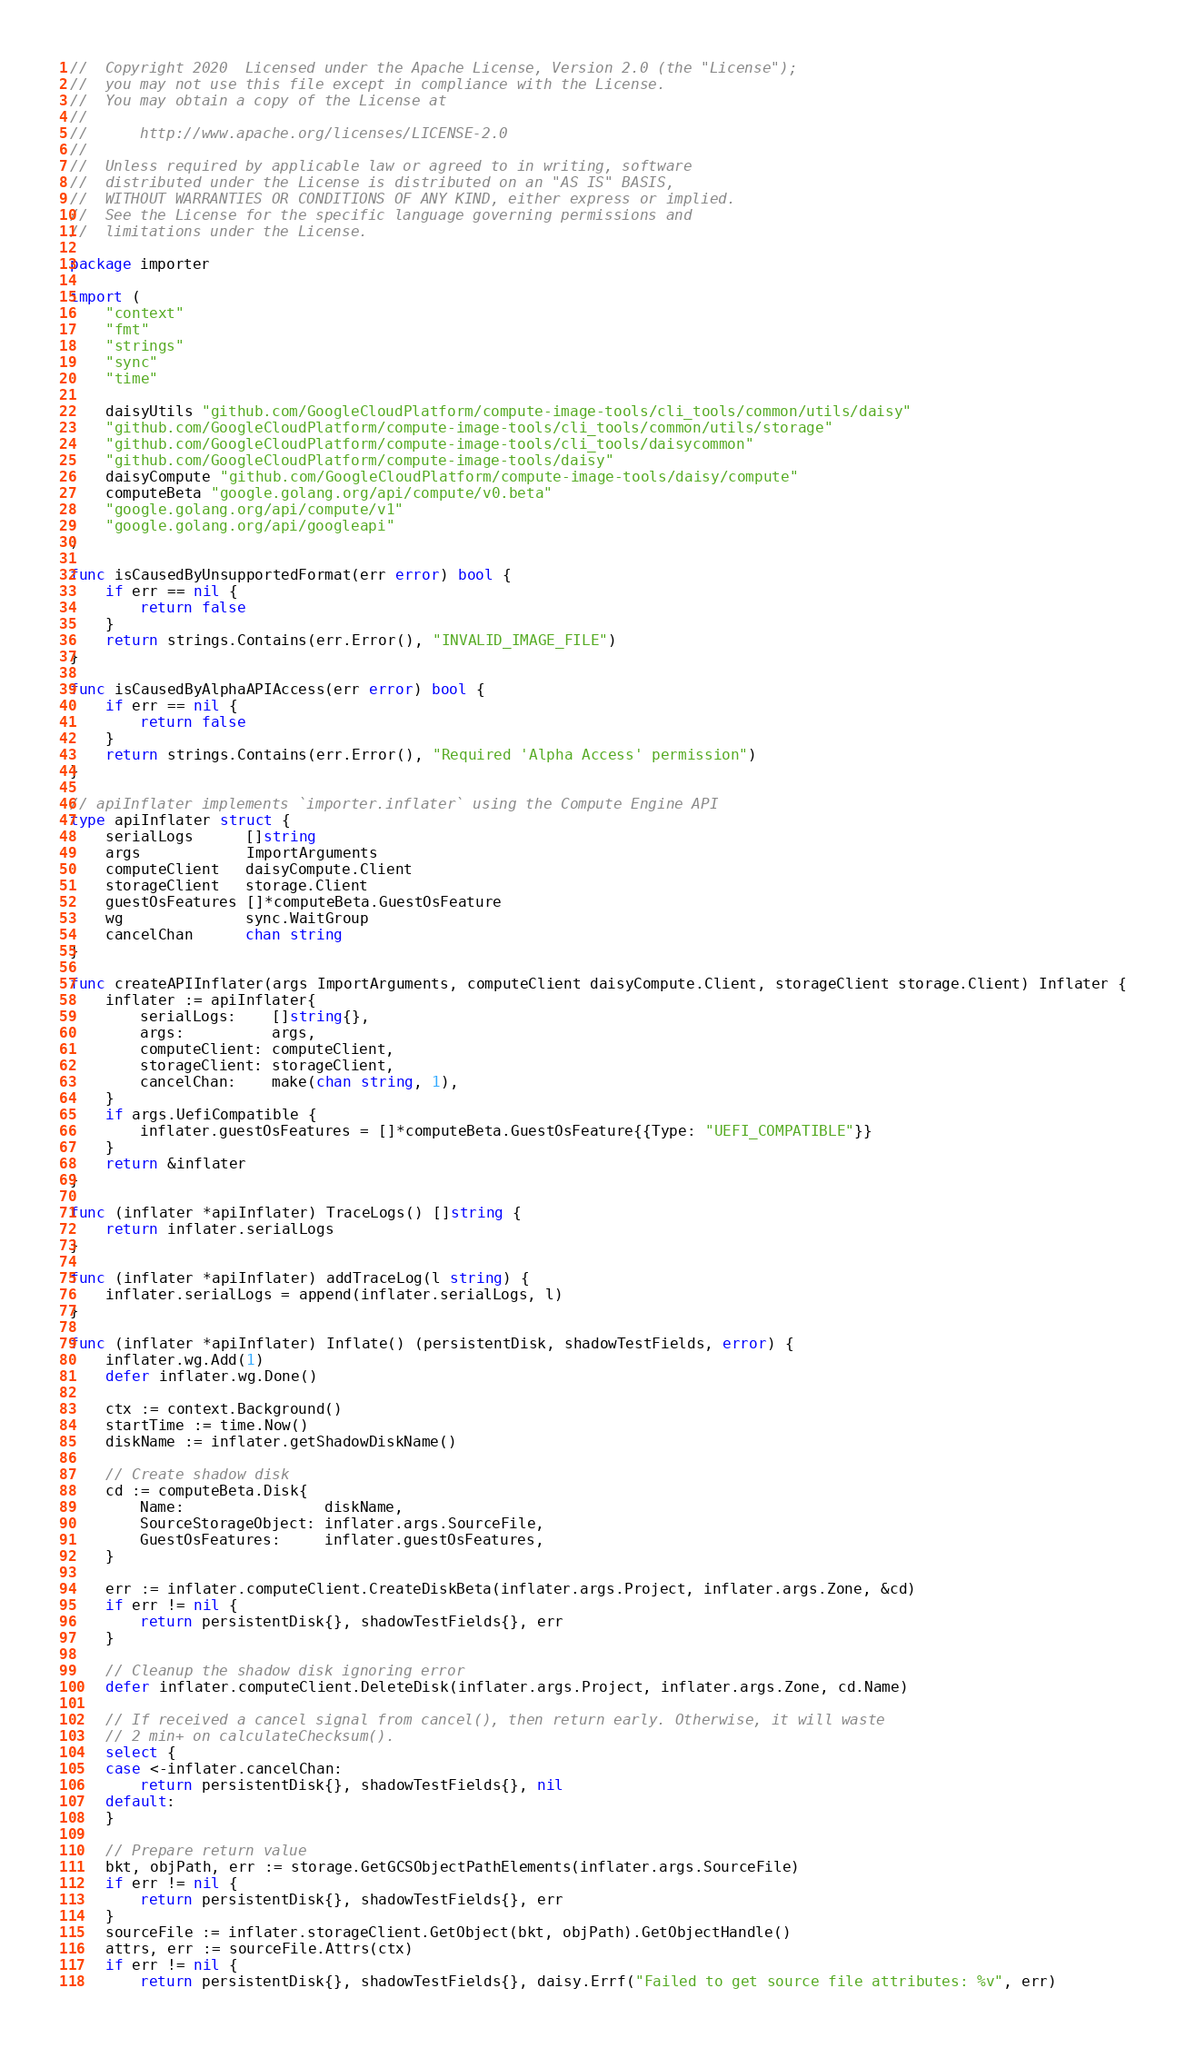<code> <loc_0><loc_0><loc_500><loc_500><_Go_>//  Copyright 2020  Licensed under the Apache License, Version 2.0 (the "License");
//  you may not use this file except in compliance with the License.
//  You may obtain a copy of the License at
//
//      http://www.apache.org/licenses/LICENSE-2.0
//
//  Unless required by applicable law or agreed to in writing, software
//  distributed under the License is distributed on an "AS IS" BASIS,
//  WITHOUT WARRANTIES OR CONDITIONS OF ANY KIND, either express or implied.
//  See the License for the specific language governing permissions and
//  limitations under the License.

package importer

import (
	"context"
	"fmt"
	"strings"
	"sync"
	"time"

	daisyUtils "github.com/GoogleCloudPlatform/compute-image-tools/cli_tools/common/utils/daisy"
	"github.com/GoogleCloudPlatform/compute-image-tools/cli_tools/common/utils/storage"
	"github.com/GoogleCloudPlatform/compute-image-tools/cli_tools/daisycommon"
	"github.com/GoogleCloudPlatform/compute-image-tools/daisy"
	daisyCompute "github.com/GoogleCloudPlatform/compute-image-tools/daisy/compute"
	computeBeta "google.golang.org/api/compute/v0.beta"
	"google.golang.org/api/compute/v1"
	"google.golang.org/api/googleapi"
)

func isCausedByUnsupportedFormat(err error) bool {
	if err == nil {
		return false
	}
	return strings.Contains(err.Error(), "INVALID_IMAGE_FILE")
}

func isCausedByAlphaAPIAccess(err error) bool {
	if err == nil {
		return false
	}
	return strings.Contains(err.Error(), "Required 'Alpha Access' permission")
}

// apiInflater implements `importer.inflater` using the Compute Engine API
type apiInflater struct {
	serialLogs      []string
	args            ImportArguments
	computeClient   daisyCompute.Client
	storageClient   storage.Client
	guestOsFeatures []*computeBeta.GuestOsFeature
	wg              sync.WaitGroup
	cancelChan      chan string
}

func createAPIInflater(args ImportArguments, computeClient daisyCompute.Client, storageClient storage.Client) Inflater {
	inflater := apiInflater{
		serialLogs:    []string{},
		args:          args,
		computeClient: computeClient,
		storageClient: storageClient,
		cancelChan:    make(chan string, 1),
	}
	if args.UefiCompatible {
		inflater.guestOsFeatures = []*computeBeta.GuestOsFeature{{Type: "UEFI_COMPATIBLE"}}
	}
	return &inflater
}

func (inflater *apiInflater) TraceLogs() []string {
	return inflater.serialLogs
}

func (inflater *apiInflater) addTraceLog(l string) {
	inflater.serialLogs = append(inflater.serialLogs, l)
}

func (inflater *apiInflater) Inflate() (persistentDisk, shadowTestFields, error) {
	inflater.wg.Add(1)
	defer inflater.wg.Done()

	ctx := context.Background()
	startTime := time.Now()
	diskName := inflater.getShadowDiskName()

	// Create shadow disk
	cd := computeBeta.Disk{
		Name:                diskName,
		SourceStorageObject: inflater.args.SourceFile,
		GuestOsFeatures:     inflater.guestOsFeatures,
	}

	err := inflater.computeClient.CreateDiskBeta(inflater.args.Project, inflater.args.Zone, &cd)
	if err != nil {
		return persistentDisk{}, shadowTestFields{}, err
	}

	// Cleanup the shadow disk ignoring error
	defer inflater.computeClient.DeleteDisk(inflater.args.Project, inflater.args.Zone, cd.Name)

	// If received a cancel signal from cancel(), then return early. Otherwise, it will waste
	// 2 min+ on calculateChecksum().
	select {
	case <-inflater.cancelChan:
		return persistentDisk{}, shadowTestFields{}, nil
	default:
	}

	// Prepare return value
	bkt, objPath, err := storage.GetGCSObjectPathElements(inflater.args.SourceFile)
	if err != nil {
		return persistentDisk{}, shadowTestFields{}, err
	}
	sourceFile := inflater.storageClient.GetObject(bkt, objPath).GetObjectHandle()
	attrs, err := sourceFile.Attrs(ctx)
	if err != nil {
		return persistentDisk{}, shadowTestFields{}, daisy.Errf("Failed to get source file attributes: %v", err)</code> 